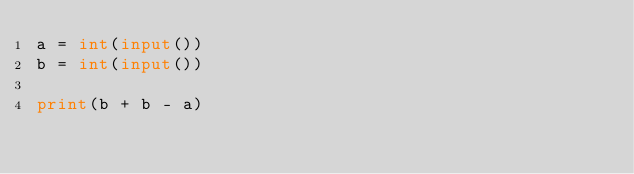Convert code to text. <code><loc_0><loc_0><loc_500><loc_500><_Python_>a = int(input())
b = int(input())

print(b + b - a)


</code> 